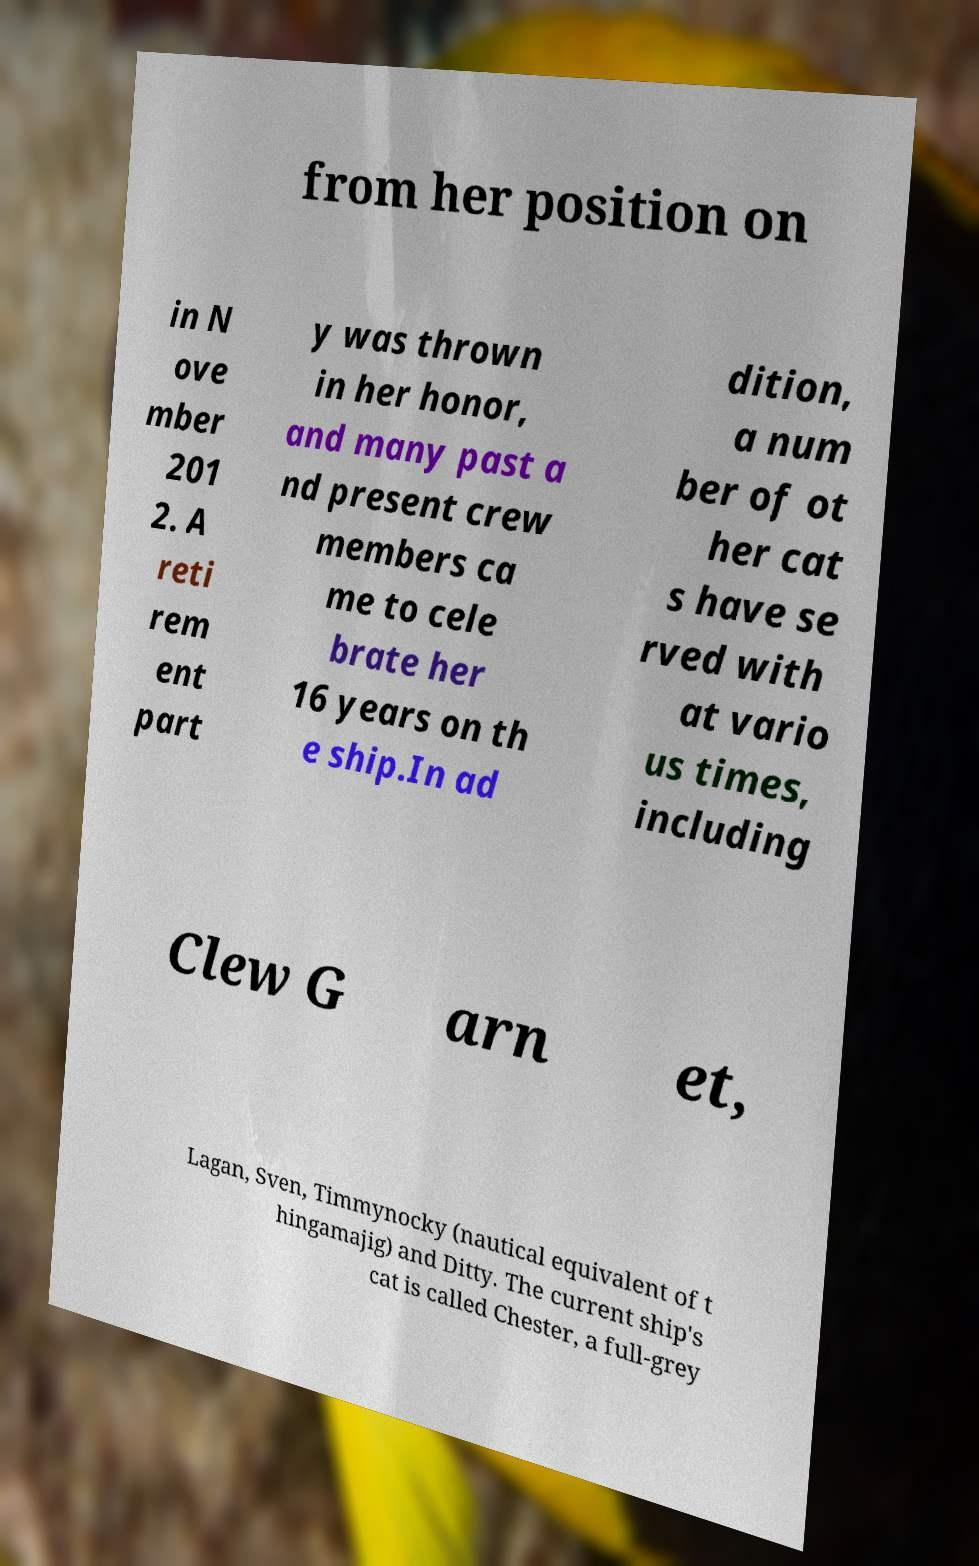I need the written content from this picture converted into text. Can you do that? from her position on in N ove mber 201 2. A reti rem ent part y was thrown in her honor, and many past a nd present crew members ca me to cele brate her 16 years on th e ship.In ad dition, a num ber of ot her cat s have se rved with at vario us times, including Clew G arn et, Lagan, Sven, Timmynocky (nautical equivalent of t hingamajig) and Ditty. The current ship's cat is called Chester, a full-grey 